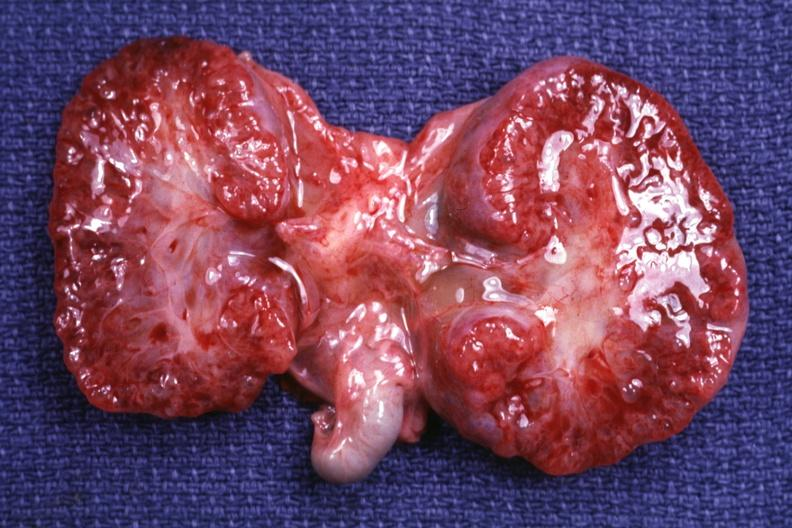s polycystic disease infant present?
Answer the question using a single word or phrase. Yes 